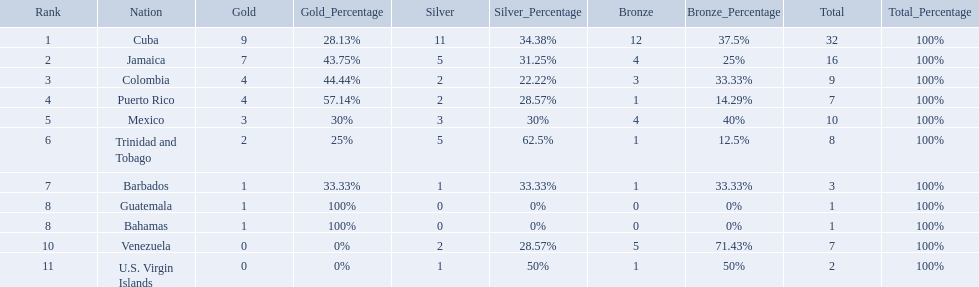What teams had four gold medals? Colombia, Puerto Rico. Of these two, which team only had one bronze medal? Puerto Rico. Which teams have at exactly 4 gold medals? Colombia, Puerto Rico. Of those teams which has exactly 1 bronze medal? Puerto Rico. Would you be able to parse every entry in this table? {'header': ['Rank', 'Nation', 'Gold', 'Gold_Percentage', 'Silver', 'Silver_Percentage', 'Bronze', 'Bronze_Percentage', 'Total', 'Total_Percentage'], 'rows': [['1', 'Cuba', '9', '28.13%', '11', '34.38%', '12', '37.5%', '32', '100%'], ['2', 'Jamaica', '7', '43.75%', '5', '31.25%', '4', '25%', '16', '100%'], ['3', 'Colombia', '4', '44.44%', '2', '22.22%', '3', '33.33%', '9', '100%'], ['4', 'Puerto Rico', '4', '57.14%', '2', '28.57%', '1', '14.29%', '7', '100%'], ['5', 'Mexico', '3', '30%', '3', '30%', '4', '40%', '10', '100%'], ['6', 'Trinidad and Tobago', '2', '25%', '5', '62.5%', '1', '12.5%', '8', '100%'], ['7', 'Barbados', '1', '33.33%', '1', '33.33%', '1', '33.33%', '3', '100%'], ['8', 'Guatemala', '1', '100%', '0', '0%', '0', '0%', '1', '100%'], ['8', 'Bahamas', '1', '100%', '0', '0%', '0', '0%', '1', '100%'], ['10', 'Venezuela', '0', '0%', '2', '28.57%', '5', '71.43%', '7', '100%'], ['11', 'U.S. Virgin Islands', '0', '0%', '1', '50%', '1', '50%', '2', '100%']]} Which countries competed in the 1966 central american and caribbean games? Cuba, Jamaica, Colombia, Puerto Rico, Mexico, Trinidad and Tobago, Barbados, Guatemala, Bahamas, Venezuela, U.S. Virgin Islands. Which countries won at least six silver medals at these games? Cuba. 